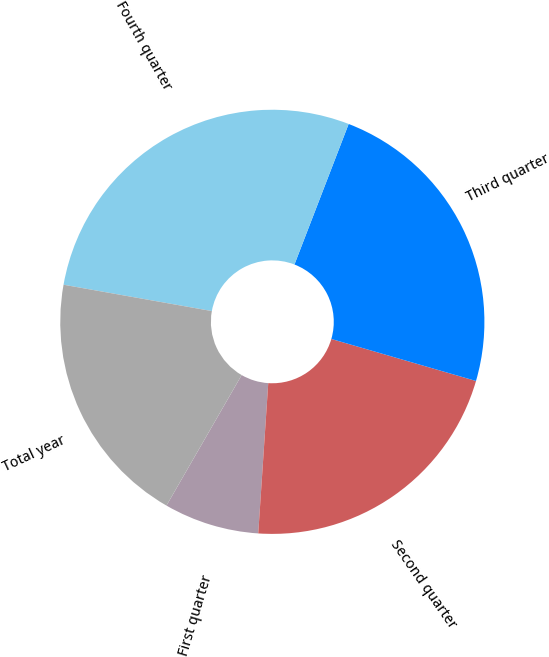<chart> <loc_0><loc_0><loc_500><loc_500><pie_chart><fcel>First quarter<fcel>Second quarter<fcel>Third quarter<fcel>Fourth quarter<fcel>Total year<nl><fcel>7.26%<fcel>21.56%<fcel>23.64%<fcel>28.06%<fcel>19.48%<nl></chart> 